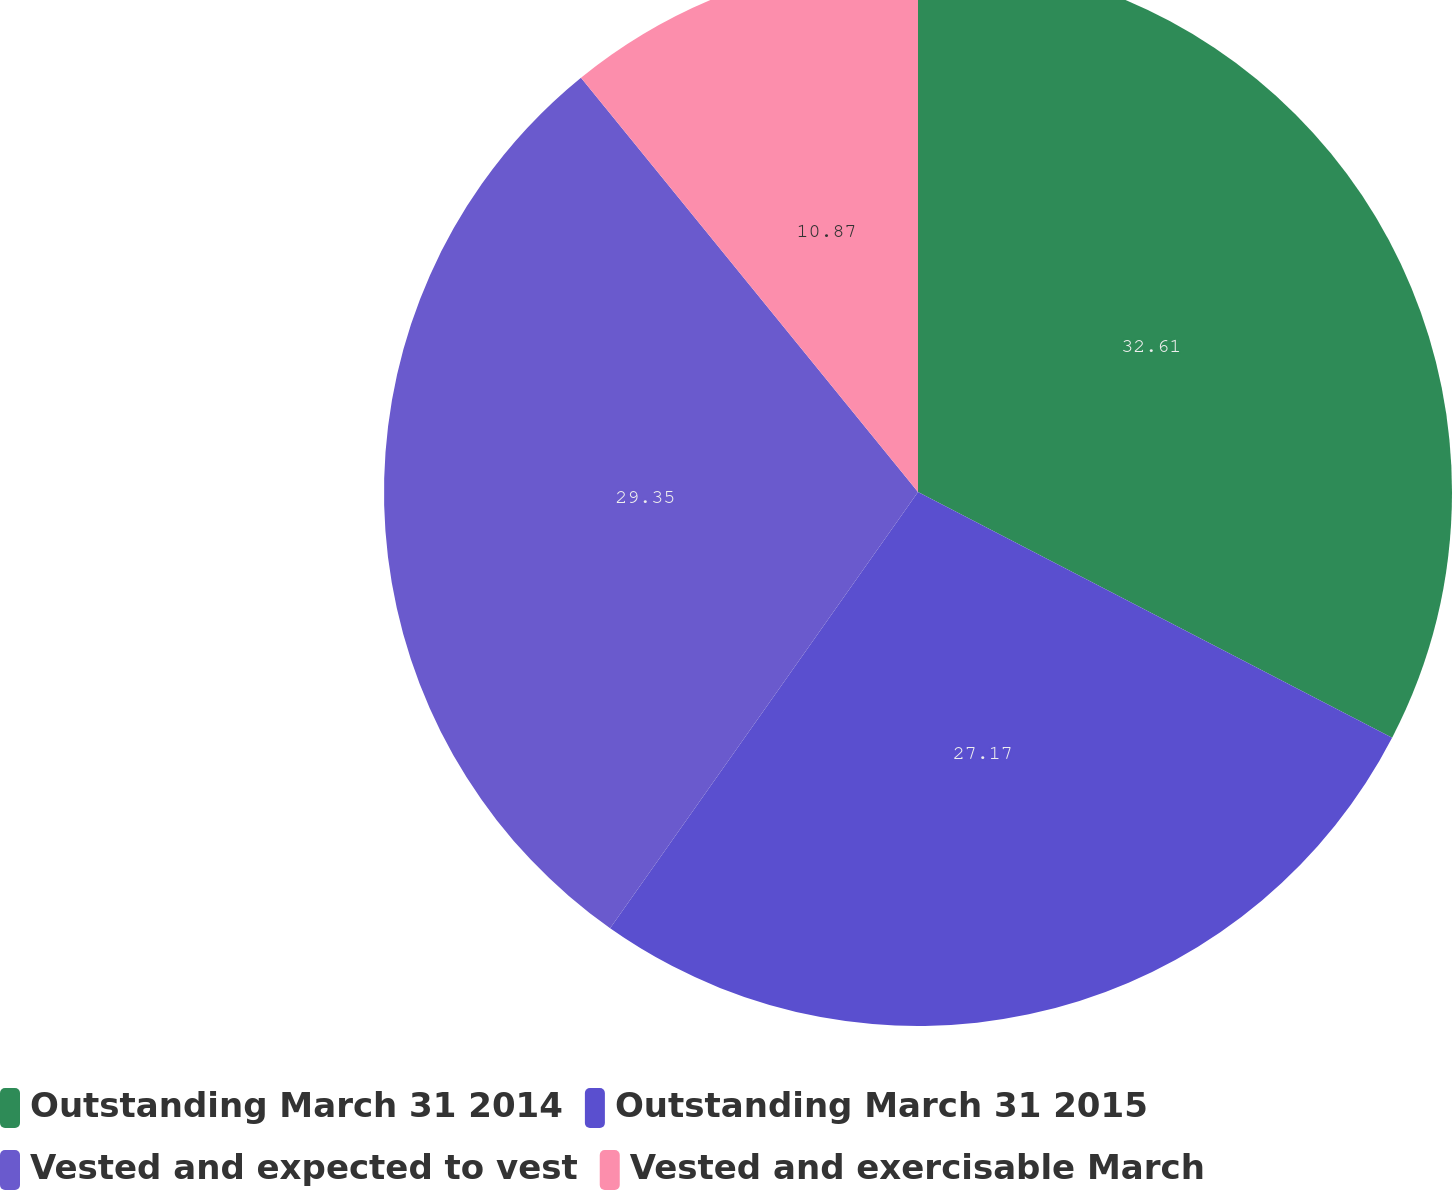Convert chart. <chart><loc_0><loc_0><loc_500><loc_500><pie_chart><fcel>Outstanding March 31 2014<fcel>Outstanding March 31 2015<fcel>Vested and expected to vest<fcel>Vested and exercisable March<nl><fcel>32.61%<fcel>27.17%<fcel>29.35%<fcel>10.87%<nl></chart> 